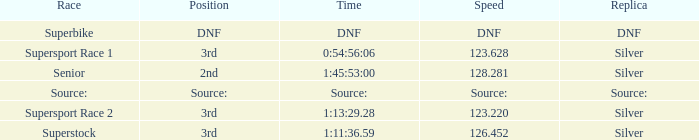Which race has a replica of DNF? Superbike. 